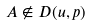<formula> <loc_0><loc_0><loc_500><loc_500>A \notin D ( u , p )</formula> 